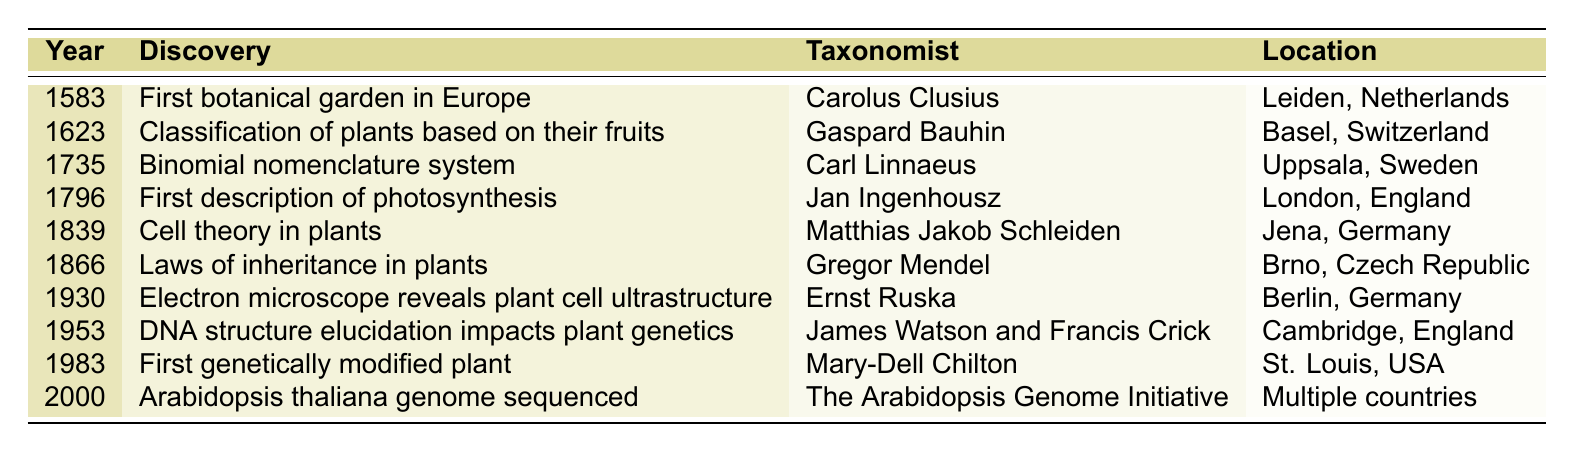What year was the first botanical garden established in Europe? According to the table, the first botanical garden in Europe was established in the year 1583.
Answer: 1583 Who discovered the laws of inheritance in plants? The table indicates that the laws of inheritance in plants were discovered by Gregor Mendel.
Answer: Gregor Mendel In which country was the binomial nomenclature system developed? The table shows that the binomial nomenclature system was developed in Uppsala, Sweden.
Answer: Sweden What was the discovery made by Jan Ingenhousz? The table lists Jan Ingenhousz as making the first description of photosynthesis in 1796.
Answer: First description of photosynthesis How many years are there between the discovery of the first botanical garden and the Arabidopsis thaliana genome sequencing? The first botanical garden was established in 1583, and the Arabidopsis thaliana genome was sequenced in 2000. The difference is 2000 - 1583 = 417 years.
Answer: 417 years Is it true that the first genetically modified plant was discovered in the 20th century? The table indicates that the first genetically modified plant was discovered in 1983, which is in the 20th century. Therefore, the statement is true.
Answer: Yes Which taxonomist was involved in discoveries both in 1735 and 1953? By checking the table, it is clear that no taxonomist appears in both years; Carl Linnaeus is associated with 1735, and James Watson & Francis Crick are associated with 1953, indicating different individuals for those years.
Answer: No Which discovery was made closest in time to the development of cell theory in plants? Referring to the table, the cell theory was proposed in 1839, and the next discovery was by Gregor Mendel in 1866, which is 27 years later. Therefore, Mendel's discovery is the closest in time.
Answer: Laws of inheritance in plants Which botanical discovery occurred first in terms of the chronology provided? The table reflects that the first botanical discovery listed is the establishment of the first botanical garden in 1583.
Answer: First botanical garden in Europe How many discoveries were made before the 20th century? By analyzing the table, six discoveries occurred before the year 1900 (1583, 1623, 1735, 1796, 1839, 1866). Counting these shows that there are six discoveries before the 20th century.
Answer: 6 